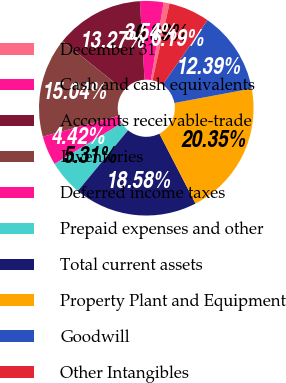Convert chart. <chart><loc_0><loc_0><loc_500><loc_500><pie_chart><fcel>December 31<fcel>Cash and cash equivalents<fcel>Accounts receivable-trade<fcel>Inventories<fcel>Deferred income taxes<fcel>Prepaid expenses and other<fcel>Total current assets<fcel>Property Plant and Equipment<fcel>Goodwill<fcel>Other Intangibles<nl><fcel>0.89%<fcel>3.54%<fcel>13.27%<fcel>15.04%<fcel>4.42%<fcel>5.31%<fcel>18.58%<fcel>20.35%<fcel>12.39%<fcel>6.19%<nl></chart> 